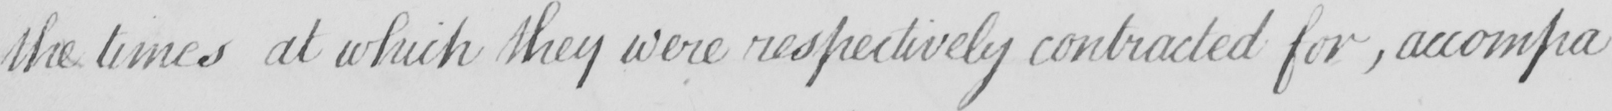Can you tell me what this handwritten text says? the times at which they were respectively contracted for , accompa- 